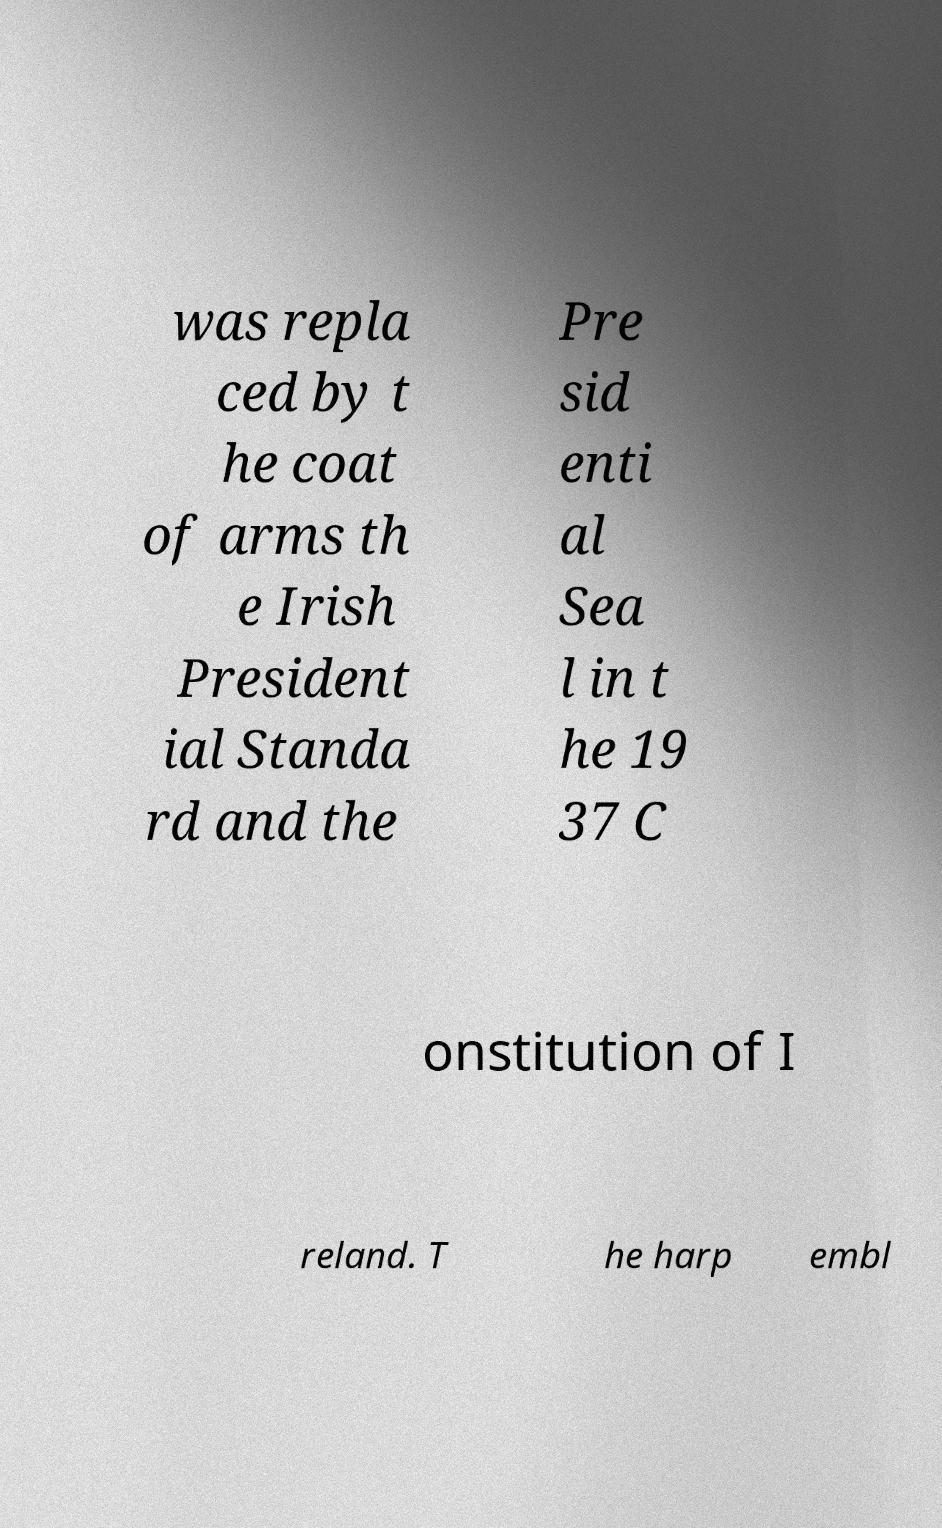Please read and relay the text visible in this image. What does it say? was repla ced by t he coat of arms th e Irish President ial Standa rd and the Pre sid enti al Sea l in t he 19 37 C onstitution of I reland. T he harp embl 